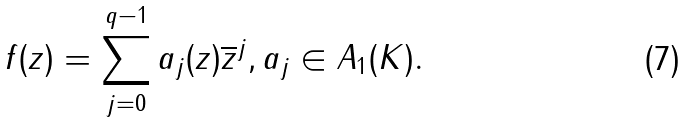<formula> <loc_0><loc_0><loc_500><loc_500>f ( z ) = \sum _ { j = 0 } ^ { q - 1 } a _ { j } ( z ) \overline { z } ^ { j } , a _ { j } \in A _ { 1 } ( K ) .</formula> 